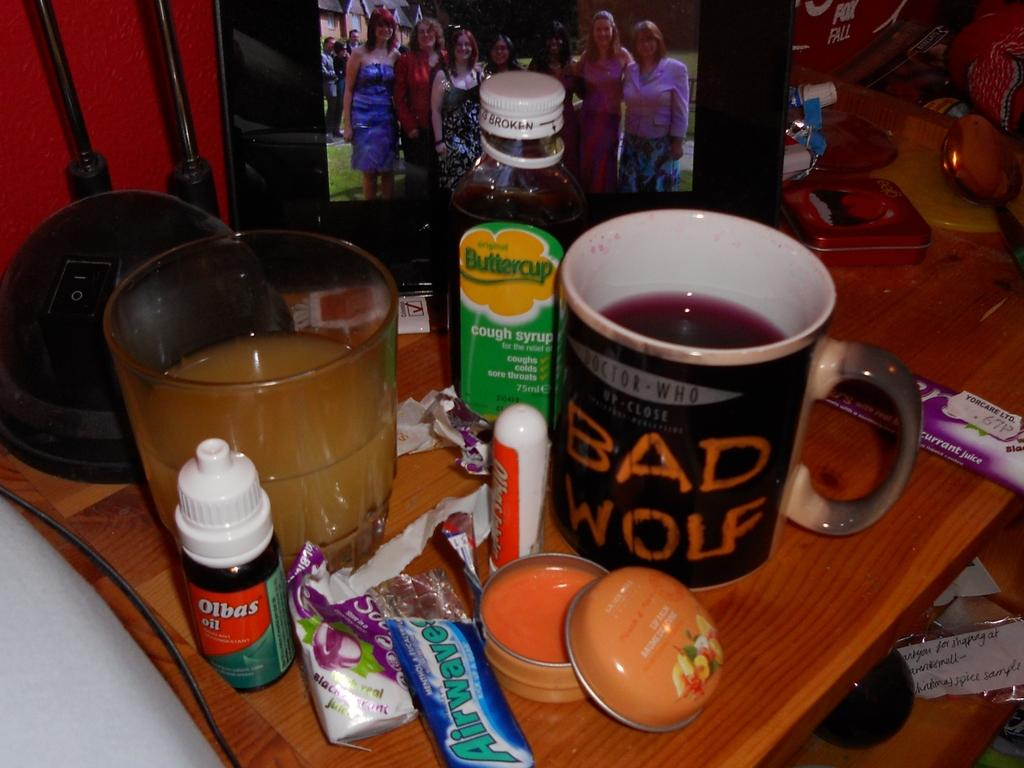<image>
Describe the image concisely. Glass of orange juice and a mug with red content that has Bad Wolf written in Orange. 